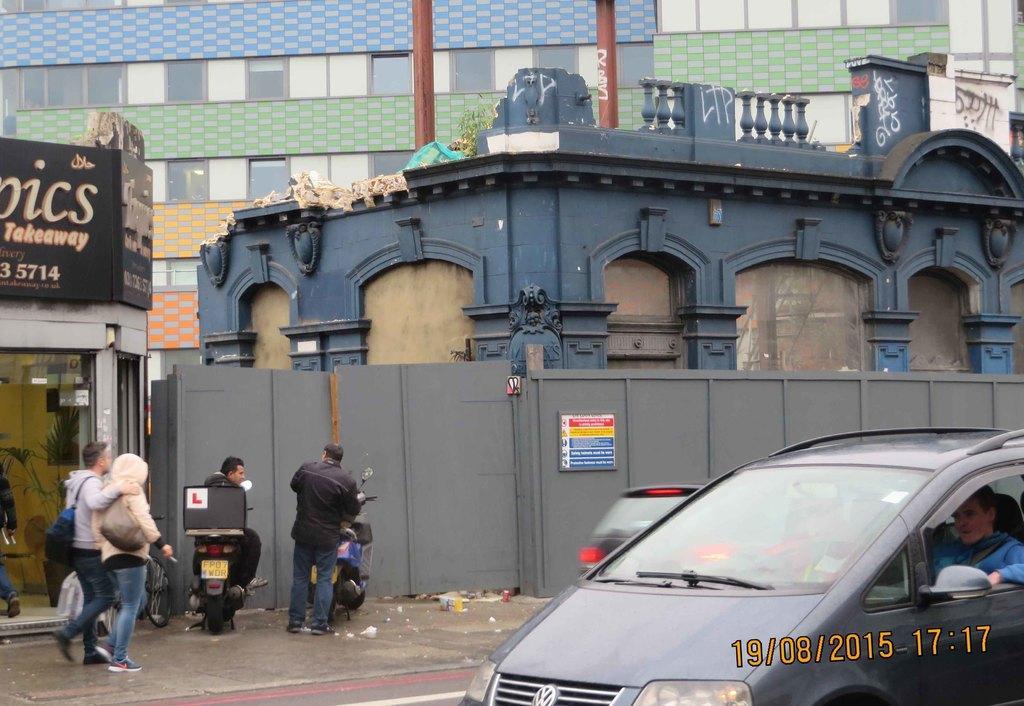Could you give a brief overview of what you see in this image? In this image i can see two persons walking on a road wearing bag, at right there are two other persons, one person sitting on a bike and the other person standing wearing black shirt and blue jeans in front of the bike at left there is a car and man sitting in a car and the other car on the road at the back ground i can see a building in the blue color, a board, a pole and a stall at the left. 